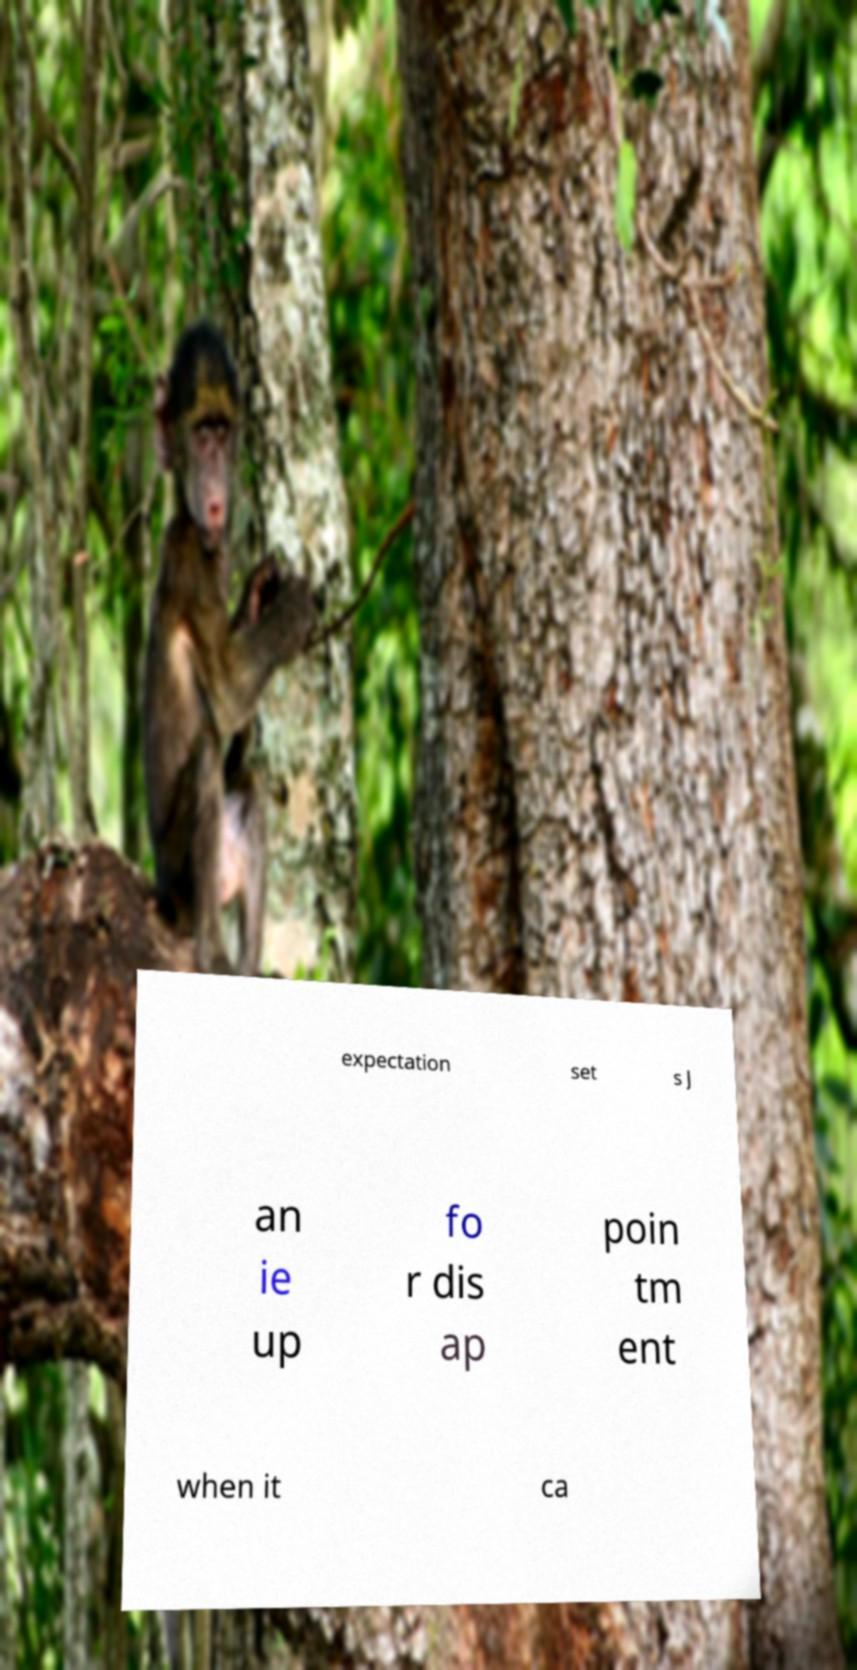Please read and relay the text visible in this image. What does it say? expectation set s J an ie up fo r dis ap poin tm ent when it ca 